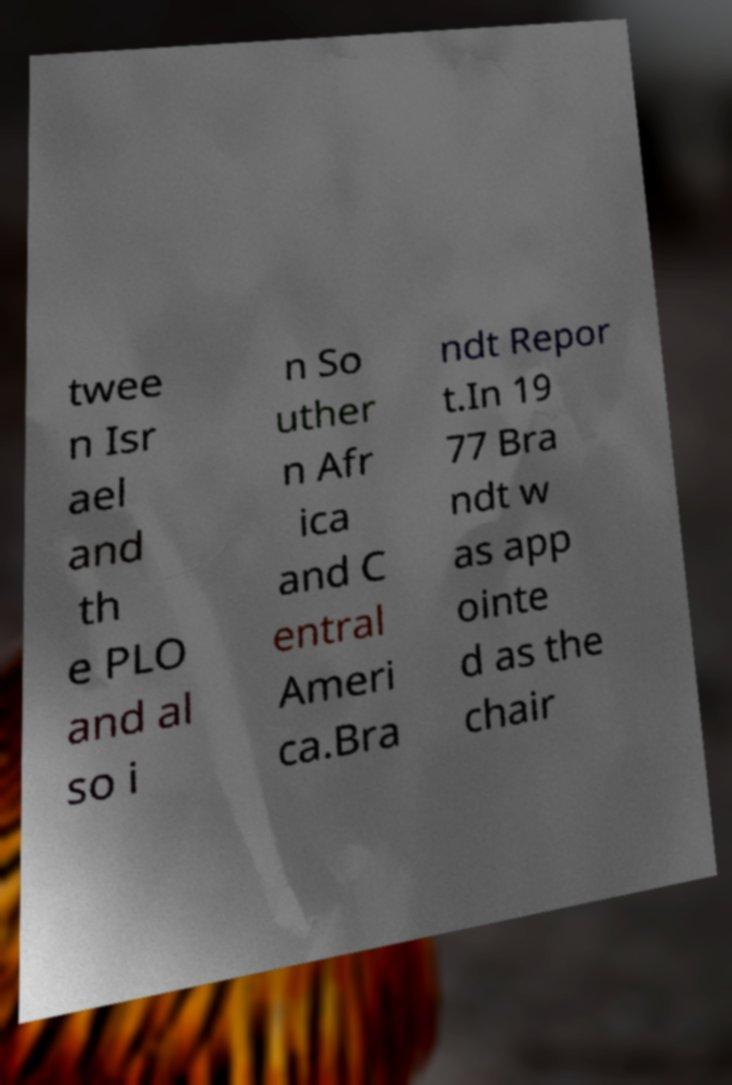There's text embedded in this image that I need extracted. Can you transcribe it verbatim? twee n Isr ael and th e PLO and al so i n So uther n Afr ica and C entral Ameri ca.Bra ndt Repor t.In 19 77 Bra ndt w as app ointe d as the chair 